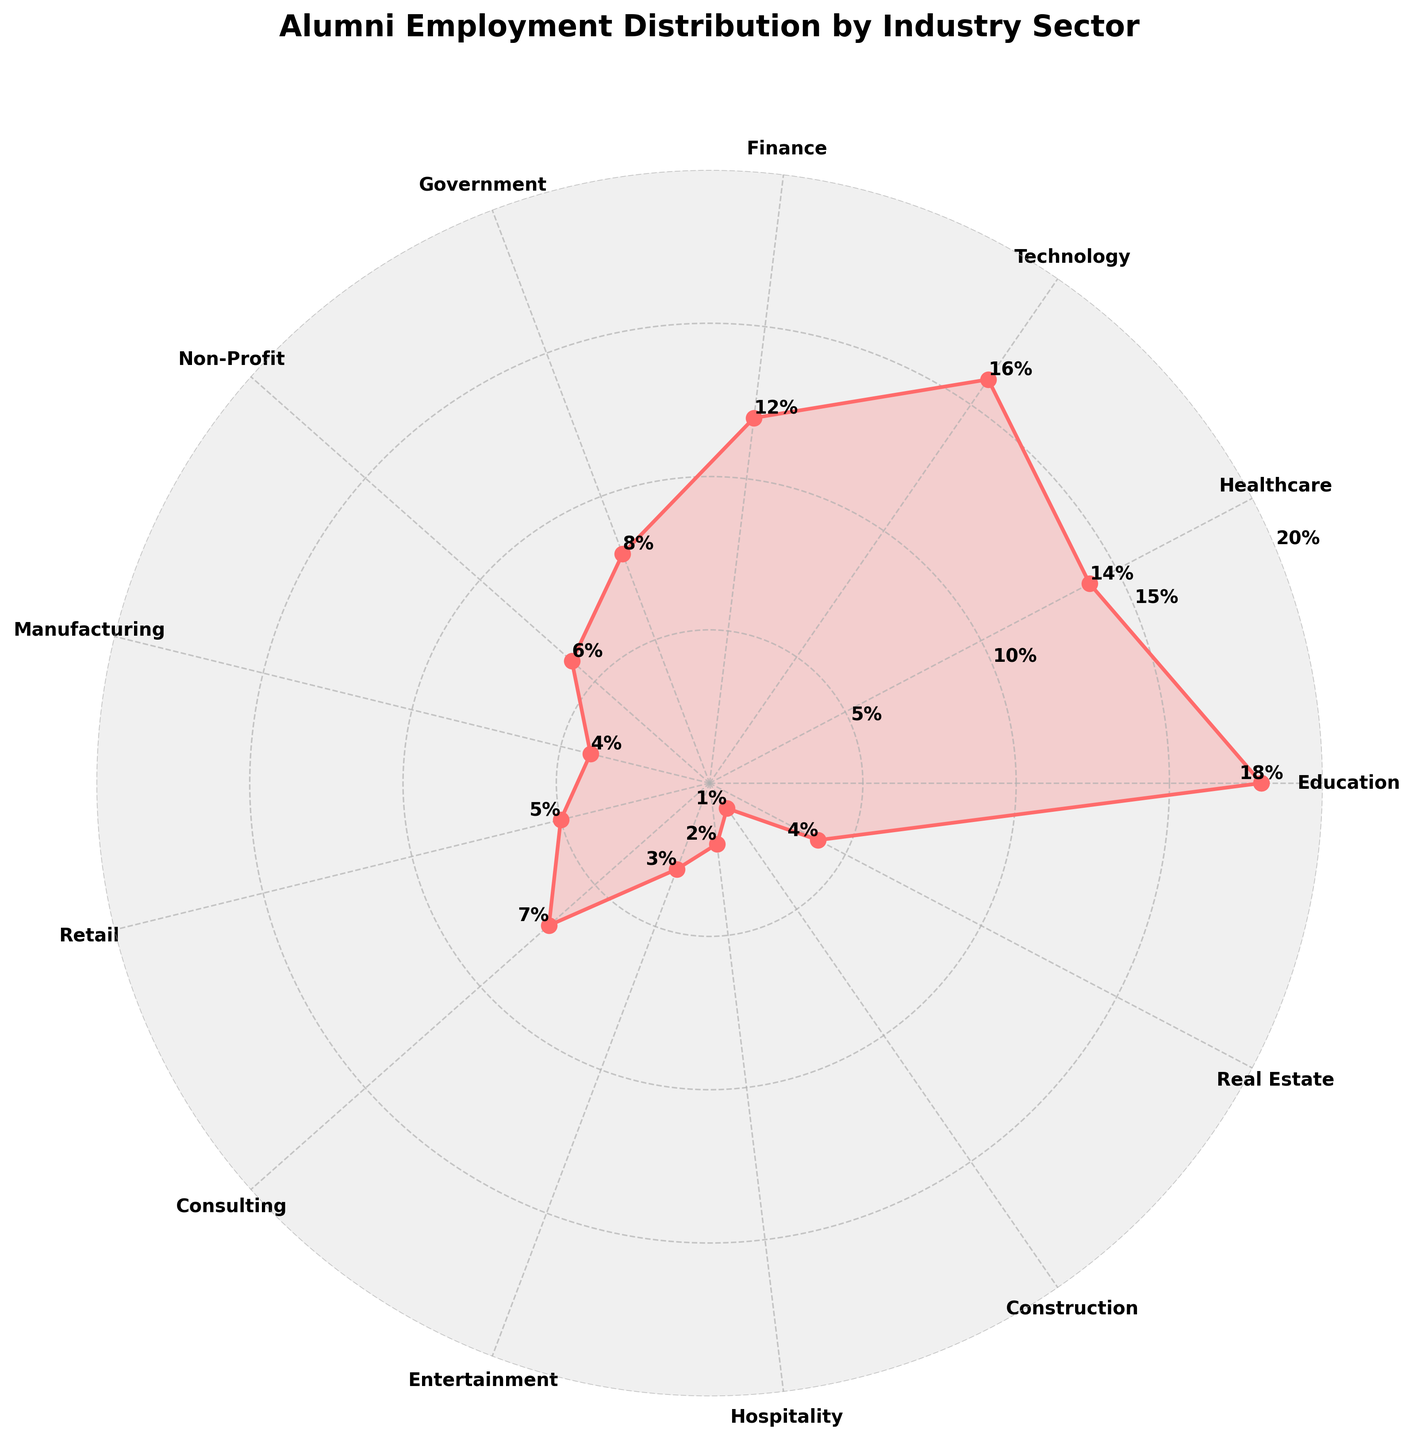What's the title of the figure? The title of the figure is displayed prominently at the top of the chart. It provides a clear description of what the chart represents.
Answer: Alumni Employment Distribution by Industry Sector Which industry sector has the highest percentage of alumni? The industry sector with the highest percentage of alumni is the one with the longest spoke on the rose chart.
Answer: Education What is the percentage of alumni in the Healthcare sector? Locate the sector labeled "Healthcare" on the rose chart and read the corresponding percentage label.
Answer: 14% What is the combined percentage of alumni in the Technology and Finance sectors? Find the percentages for both Technology and Finance sectors and add them together: 16% + 12%.
Answer: 28% Which industry sectors have a lower alumni percentage than the Government sector? Identify sectors with spokes shorter than Government, which has an 8% alumni share. Compare each sector’s percentage: Non-Profit, Manufacturing, Retail, Consulting, Entertainment, Hospitality, Construction, and Real Estate.
Answer: Non-Profit, Manufacturing, Retail, Entertainment, Hospitality, and Construction How many industry sectors have a percentage of alumni greater than 10%? Count the number of sectors with percentages above 10%: Education, Healthcare, Technology, and Finance, each with more than 10%.
Answer: 4 What's the percentage difference between the Education and Entertainment sectors? Subtract the percentage of the Entertainment sector from the Education sector: 18% - 3%.
Answer: 15% Which sectors have an equal percentage of alumni? Look for spokes that are the same length. Construction and Real Estate both have 4%.
Answer: Manufacturing and Real Estate If the combined percentage of Consulting and Non-Profit sectors were to double, what would be the new percentage? Add their percentages: 7% + 6% = 13%, then double it: 13% * 2 = 26%.
Answer: 26% What is the average percentage of alumni across all sectors? Sum all the percentages and divide by the number of sectors: (18% + 14% + 16% + 12% + 8% + 6% + 4% + 5% + 7% + 3% + 2% + 1% + 4%) / 13.
Answer: 7.69% 